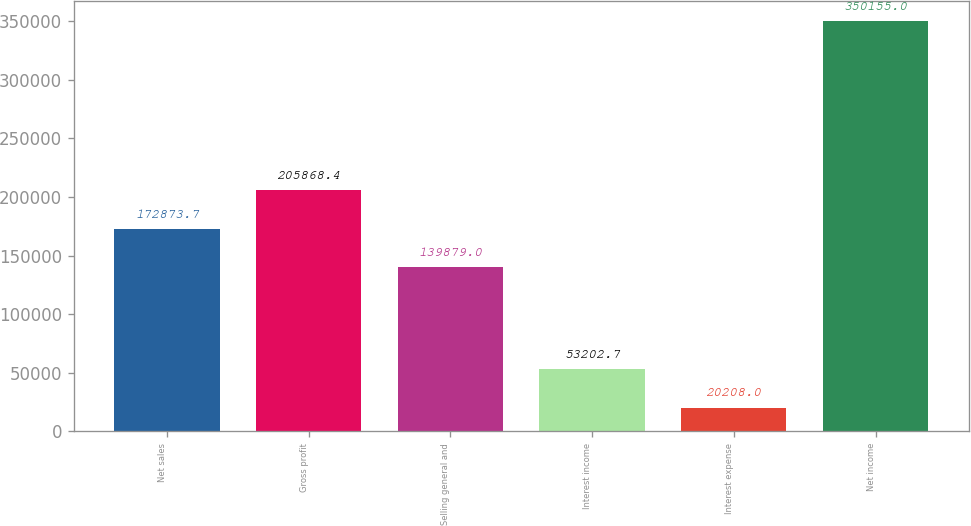<chart> <loc_0><loc_0><loc_500><loc_500><bar_chart><fcel>Net sales<fcel>Gross profit<fcel>Selling general and<fcel>Interest income<fcel>Interest expense<fcel>Net income<nl><fcel>172874<fcel>205868<fcel>139879<fcel>53202.7<fcel>20208<fcel>350155<nl></chart> 